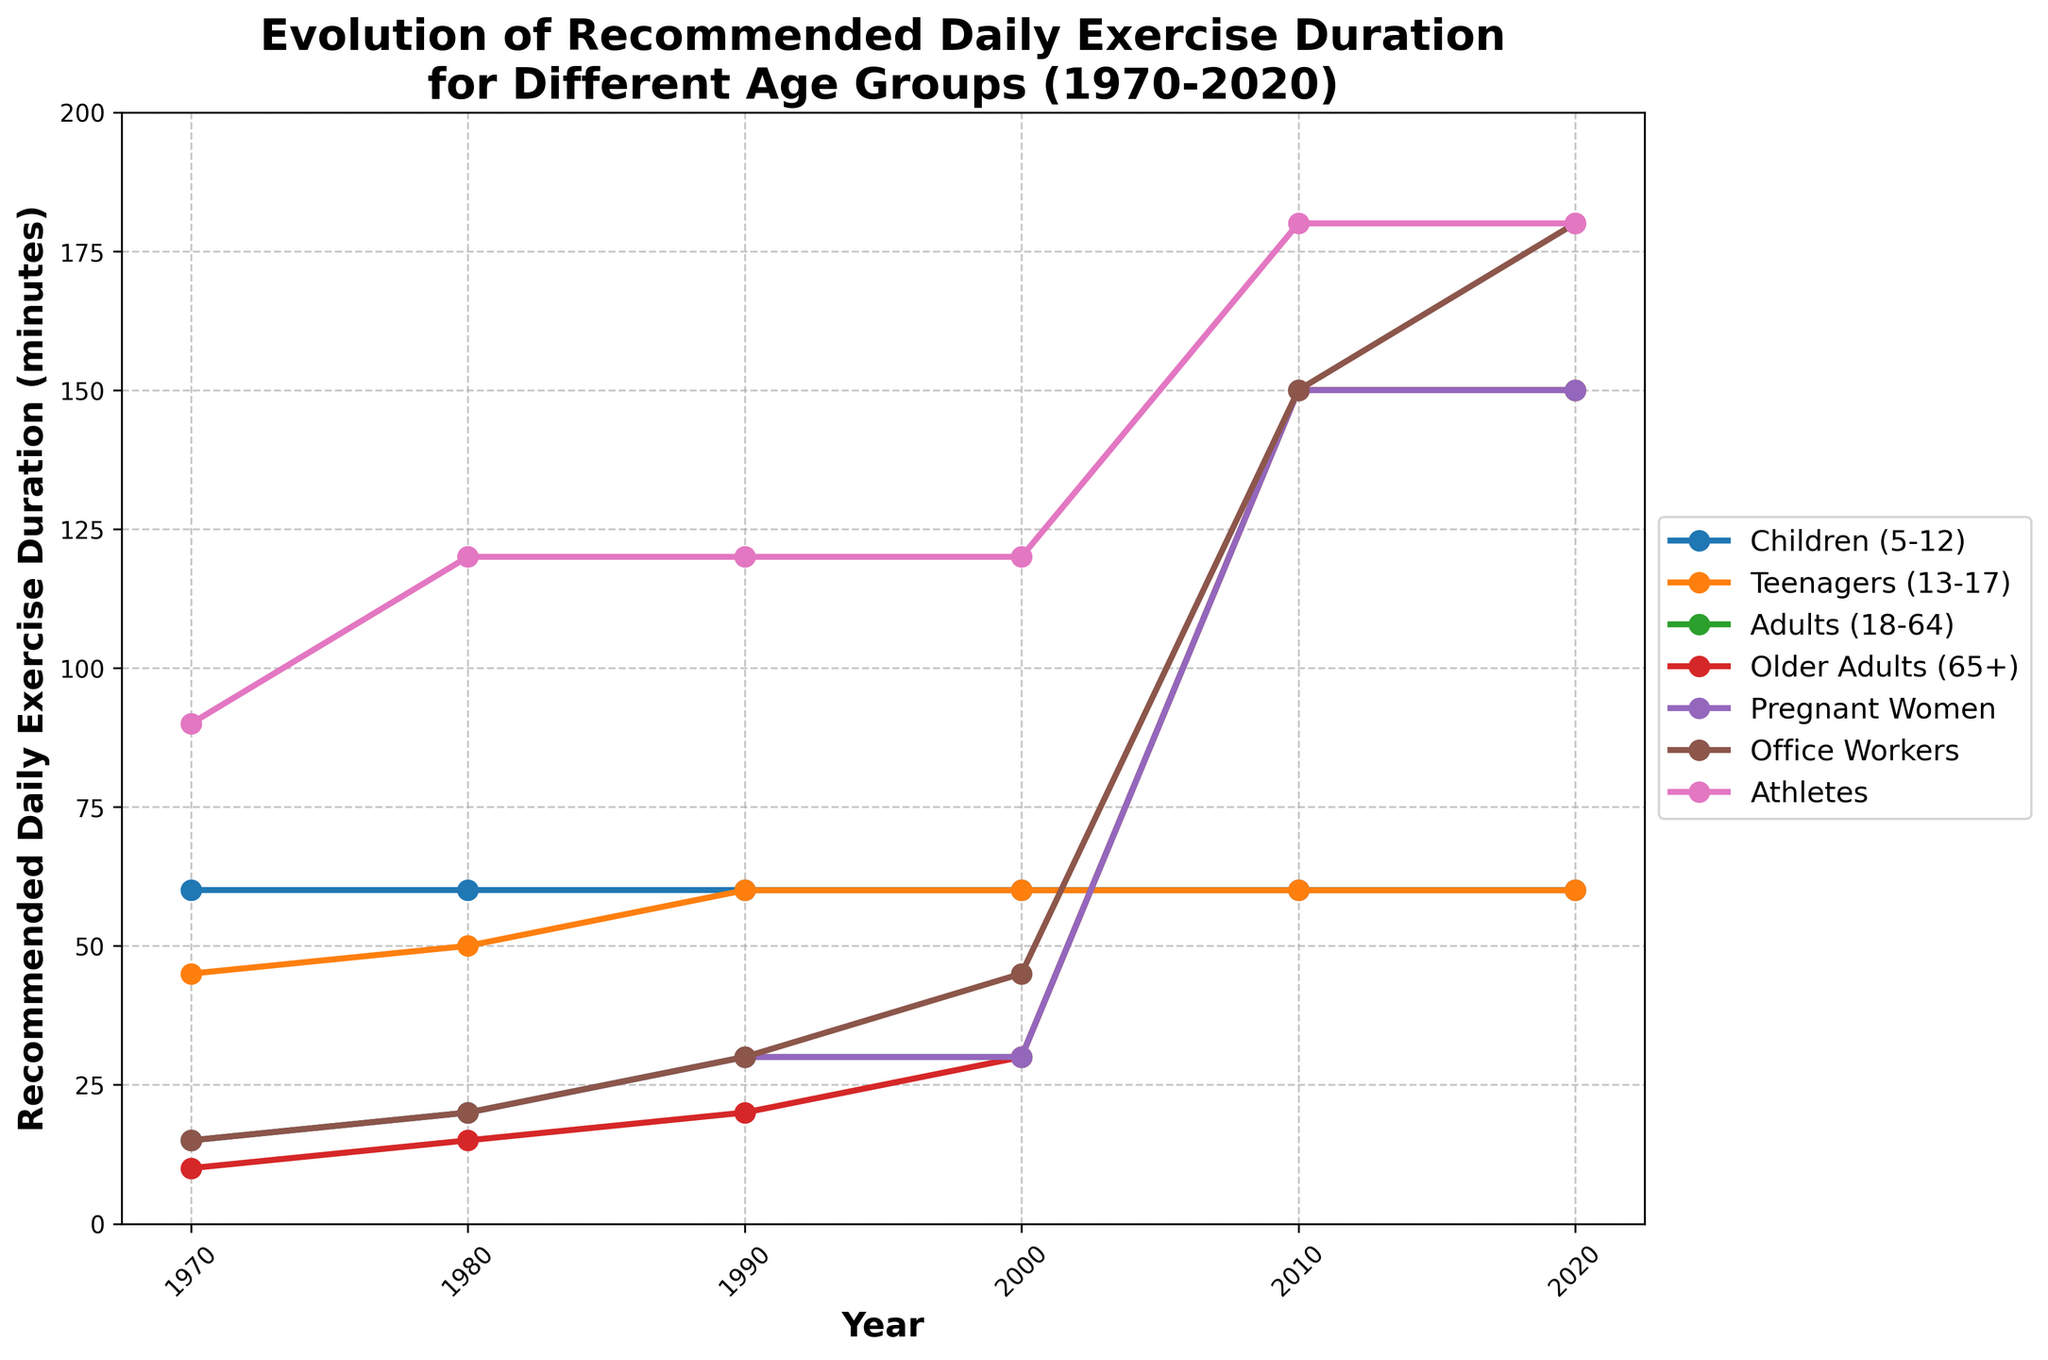What changes can be observed in the exercise recommendations for adults (18-64) between 1990 and 2020? To determine the changes, observe the line corresponding to "Adults (18-64)" and compare the values at the years 1990 and 2020. In 1990, the recommended daily exercise duration was 30 minutes, while in 2020, it increased significantly to 150 minutes.
Answer: The recommended daily exercise duration for adults (18-64) increased from 30 minutes to 150 minutes Which age group had the most significant increase in recommended daily exercise duration from 1980 to 2010? To identify this, compare the differences in recommended exercise duration between 1980 and 2010 for each age group. Look at how much each line's value increased over this period. The greatest increase is observed in "Office Workers," which went from 20 minutes in 1980 to 150 minutes in 2010, a difference of 130 minutes.
Answer: Office Workers By how much did the recommended exercise duration for teenagers (13-17) change between 1970 and 1990? Examine the "Teenagers (13-17)" line and note the values for 1970 and 1990. In 1970, it was 45 minutes, and in 1990, it was 60 minutes. The difference is 60 - 45 = 15 minutes.
Answer: 15 minutes How does the recommendation for pregnant women in 2020 compare to the recommendation for athletes in 1990? Observe the values for "Pregnant Women" in 2020 and "Athletes" in 1990. Each is 150 minutes and 120 minutes, respectively. Thus, the recommendation for pregnant women in 2020 is higher by 150 - 120 = 30 minutes.
Answer: Pregnant women's recommendation is 30 minutes higher than athletes' recommendation in 1990 What's the average recommended daily exercise duration in 1980 for all age groups? To compute the average, sum all the values for 1980 and divide by the number of age groups. Total = 60 (Children) + 50 (Teenagers) + 20 (Adults) + 15 (Older Adults) + 20 (Pregnant Women) + 20 (Office Workers) + 120 (Athletes) = 305. There are 7 groups, so the average is 305 / 7 ≈ 43.57 minutes.
Answer: 43.57 minutes Which age group(s) had no changes in their recommended daily exercise duration over the past 50 years? Look for lines that are horizontal, indicating no changes in their value. The line for "Children (5-12)" remains at 60 minutes throughout all years, meaning this age group had no changes.
Answer: Children (5-12) In which year did office workers see their first significant increase in exercise recommendations? Observe the "Office Workers" line and identify the year when the value had a major jump. The initial increase happened in 2000 when the recommendation increased to 45 minutes from 30 minutes in 1990.
Answer: 2000 